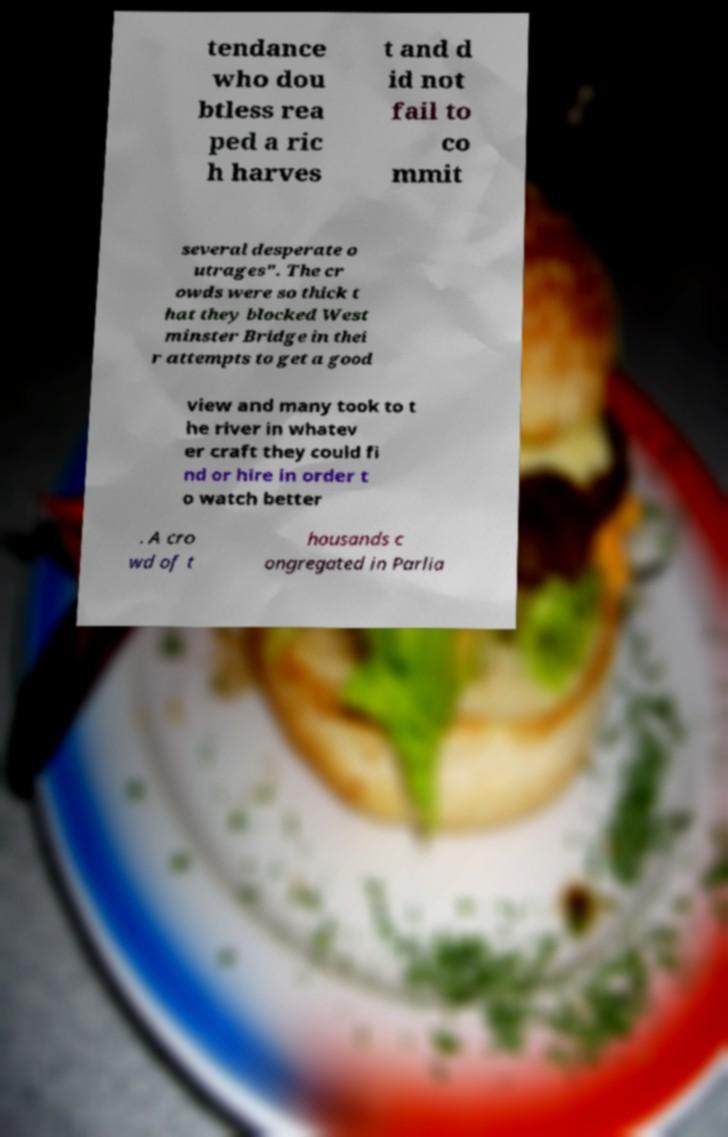There's text embedded in this image that I need extracted. Can you transcribe it verbatim? tendance who dou btless rea ped a ric h harves t and d id not fail to co mmit several desperate o utrages". The cr owds were so thick t hat they blocked West minster Bridge in thei r attempts to get a good view and many took to t he river in whatev er craft they could fi nd or hire in order t o watch better . A cro wd of t housands c ongregated in Parlia 